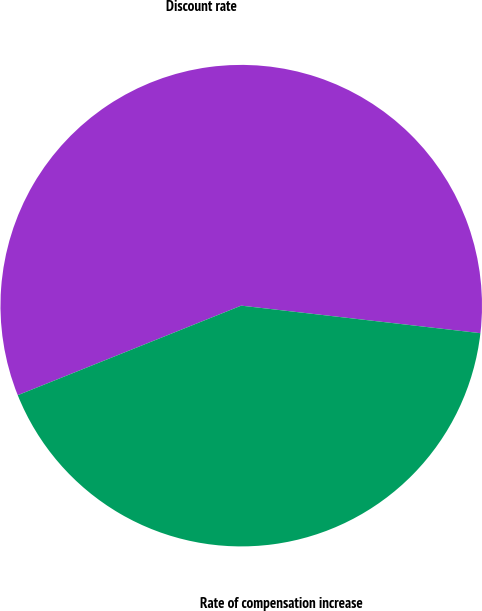<chart> <loc_0><loc_0><loc_500><loc_500><pie_chart><fcel>Discount rate<fcel>Rate of compensation increase<nl><fcel>57.89%<fcel>42.11%<nl></chart> 